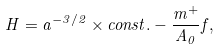<formula> <loc_0><loc_0><loc_500><loc_500>H = a ^ { - 3 / 2 } \times c o n s t . - \frac { m ^ { + } } { A _ { 0 } } f ,</formula> 